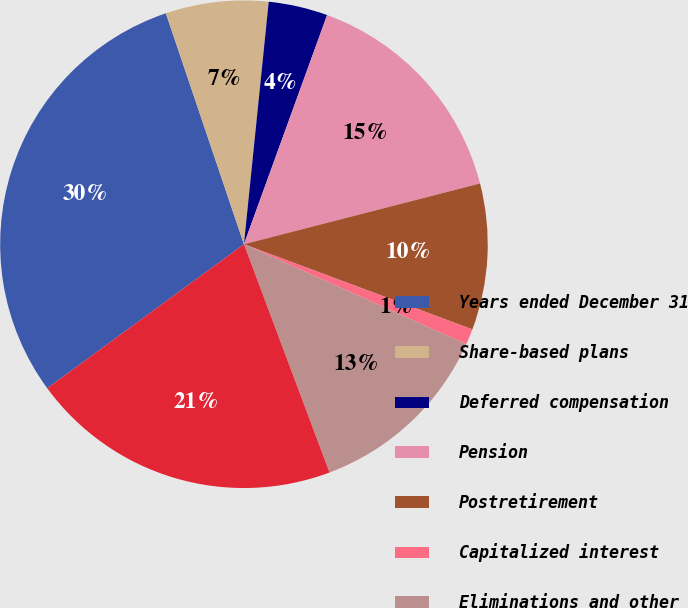Convert chart. <chart><loc_0><loc_0><loc_500><loc_500><pie_chart><fcel>Years ended December 31<fcel>Share-based plans<fcel>Deferred compensation<fcel>Pension<fcel>Postretirement<fcel>Capitalized interest<fcel>Eliminations and other<fcel>Total<nl><fcel>29.87%<fcel>6.81%<fcel>3.92%<fcel>15.45%<fcel>9.69%<fcel>1.04%<fcel>12.57%<fcel>20.65%<nl></chart> 